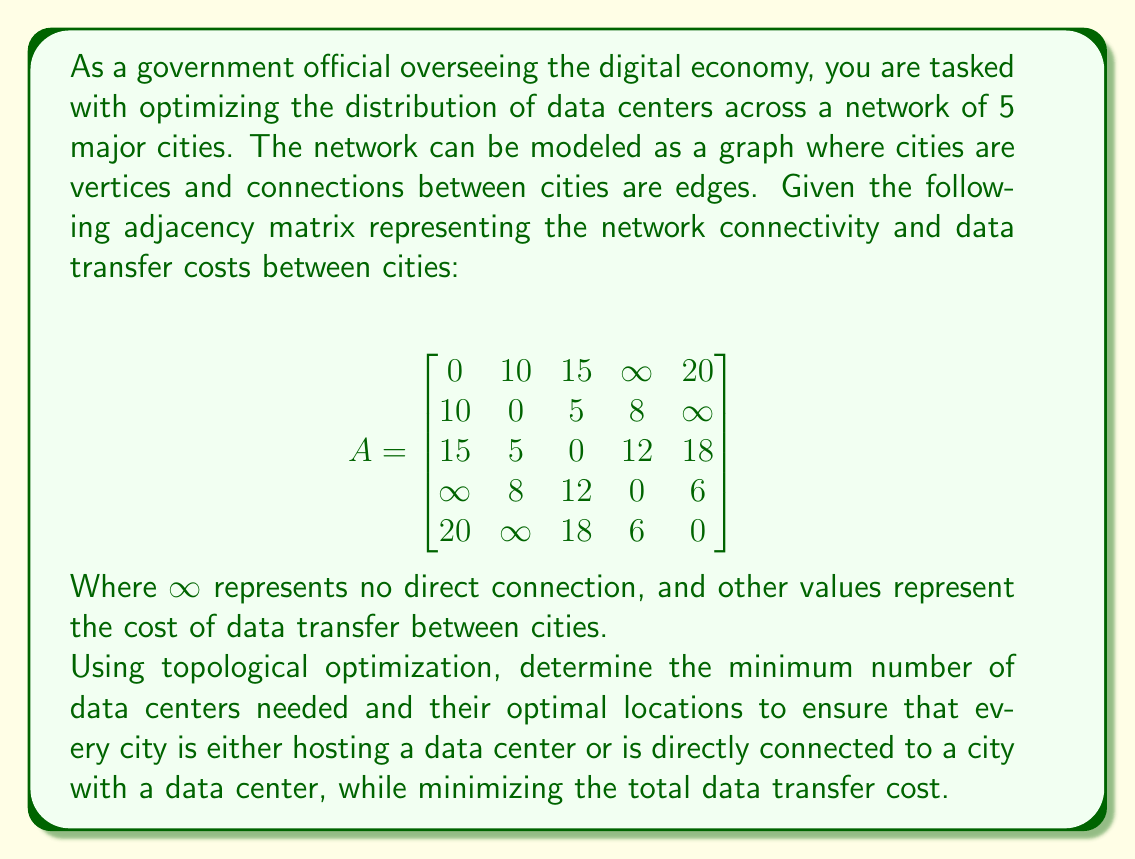Can you solve this math problem? To solve this problem, we'll use a topological optimization approach based on the dominating set concept in graph theory. The goal is to find the minimum dominating set, where each vertex in the graph is either in the set or adjacent to a vertex in the set.

Step 1: Analyze the connectivity
First, we need to understand the network structure:
- City 1 is connected to cities 2, 3, and 5
- City 2 is connected to cities 1, 3, and 4
- City 3 is connected to all other cities
- City 4 is connected to cities 2, 3, and 5
- City 5 is connected to cities 1, 3, and 4

Step 2: Identify potential optimal locations
City 3 stands out as it's connected to all other cities, making it a strong candidate for a data center location.

Step 3: Consider minimal coverage
If we place a data center in City 3, it covers all cities. However, we need to check if this is the most cost-effective solution.

Step 4: Calculate total data transfer cost
If we place the data center in City 3, the total data transfer cost would be:
$15 + 5 + 0 + 12 + 18 = 50$

Step 5: Check alternative configurations
We could consider placing two data centers to potentially reduce costs. For example:
- Cities 2 and 5: Covers all cities with cost $10 + 5 + 8 + 6 = 29$
- Cities 1 and 4: Covers all cities with cost $10 + 15 + 8 + 6 = 39$

Step 6: Optimize for cost and number of centers
The configuration with data centers in Cities 2 and 5 provides the lowest total data transfer cost while ensuring all cities are covered.

Step 7: Verify the solution
With data centers in Cities 2 and 5:
- City 1 is connected to City 2 (cost 10)
- City 2 hosts a data center (cost 0)
- City 3 is connected to City 2 (cost 5)
- City 4 is connected to City 5 (cost 6)
- City 5 hosts a data center (cost 0)

Total cost: $10 + 0 + 5 + 6 + 0 = 21$

This configuration provides the optimal solution, minimizing both the number of data centers and the total data transfer cost.
Answer: The optimal distribution requires 2 data centers, located in Cities 2 and 5, with a total data transfer cost of 21. 